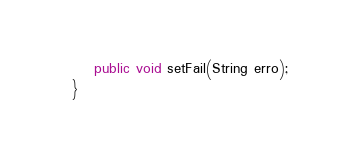Convert code to text. <code><loc_0><loc_0><loc_500><loc_500><_Java_>    public void setFail(String erro);
}
</code> 